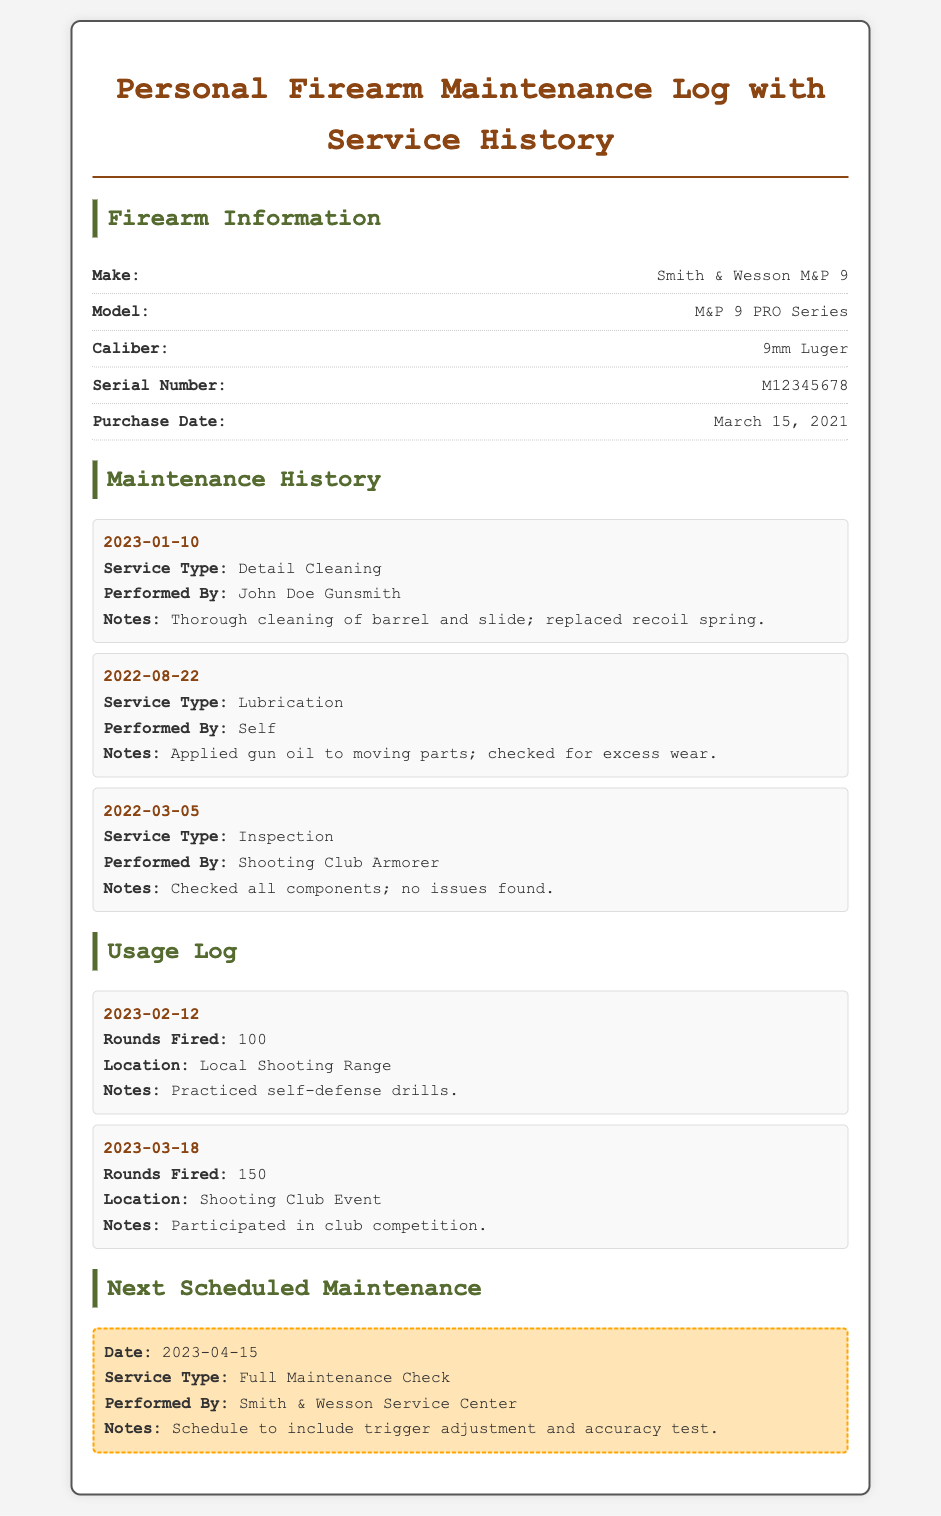What is the make of the firearm? The make of the firearm is stated in the "Firearm Information" section.
Answer: Smith & Wesson M&P 9 What was the service type performed on January 10, 2023? The service type for the maintenance history on the specified date is listed in the maintenance history section.
Answer: Detail Cleaning Who performed the lubrication service? The maintainer's name for the lubrication service is mentioned in the maintenance history section.
Answer: Self How many rounds were fired on March 18, 2023? The number of rounds fired is recorded in the usage log for that date.
Answer: 150 What date is the next scheduled maintenance? The date for the next scheduled maintenance is specified in the "Next Scheduled Maintenance" section of the document.
Answer: 2023-04-15 What was the location for the usage on February 12, 2023? The location is listed under the corresponding usage log entry.
Answer: Local Shooting Range What is the serial number of the firearm? The serial number is provided in the "Firearm Information" section of the document.
Answer: M12345678 What type of maintenance is scheduled for April 15, 2023? The type of maintenance is described in the next scheduled maintenance section.
Answer: Full Maintenance Check Who performed the inspection on March 5, 2022? The name of the person who performed the inspection is noted in the maintenance history.
Answer: Shooting Club Armorer 